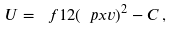<formula> <loc_0><loc_0><loc_500><loc_500>U = \ f 1 2 ( \ p x v ) ^ { 2 } - C \, ,</formula> 